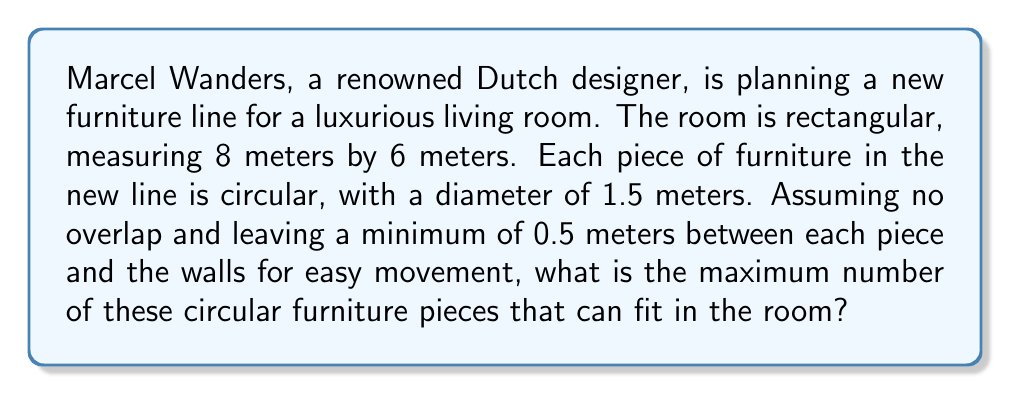Can you solve this math problem? To solve this problem, we need to follow these steps:

1. Calculate the effective area of the room after accounting for the 0.5m buffer zone along the walls:
   $$\text{Effective length} = 8 - (2 \times 0.5) = 7\text{ m}$$
   $$\text{Effective width} = 6 - (2 \times 0.5) = 5\text{ m}$$
   $$\text{Effective area} = 7 \times 5 = 35\text{ m}^2$$

2. Calculate the area occupied by each piece of furniture:
   $$\text{Radius} = 1.5 \div 2 = 0.75\text{ m}$$
   $$\text{Area per piece} = \pi r^2 = \pi \times 0.75^2 \approx 1.77\text{ m}^2$$

3. Calculate the maximum number of pieces that can fit:
   $$\text{Maximum pieces} = \left\lfloor\frac{\text{Effective area}}{\text{Area per piece}}\right\rfloor = \left\lfloor\frac{35}{1.77}\right\rfloor = \left\lfloor19.77\right\rfloor = 19$$

   Note: We use the floor function $\lfloor \rfloor$ to round down to the nearest whole number, as we can't have a fractional piece of furniture.

4. Verify that this arrangement is feasible:
   The effective dimensions (7m x 5m) can accommodate a 4 x 5 grid of circles with 1.5m diameter, which would be 20 pieces. Our calculation of 19 pieces is slightly less than this, confirming that it's a realistic arrangement.

[asy]
unitsize(20);
pen circlePen = rgb(0.7,0.7,1) + linewidth(0.8);
pen roomPen = rgb(0.9,0.9,0.9) + linewidth(1.5);

fill(box((0,0),(8,6)), rgb(0.95,0.95,0.95));
draw(box((0,0),(8,6)), roomPen);
draw(box((0.5,0.5),(7.5,5.5)), roomPen+dashed);

for(int i = 0; i < 4; ++i) {
    for(int j = 0; j < 5; ++j) {
        if(i*5 + j < 19) {
            fill(circle((1.25+1.5*i, 1+1.5*j), 0.75), circlePen);
        }
    }
}

label("8m", (4,-0.3), S);
label("6m", (8.3,3), E);
[/asy]
Answer: The maximum number of circular furniture pieces that can fit in the room is 19. 